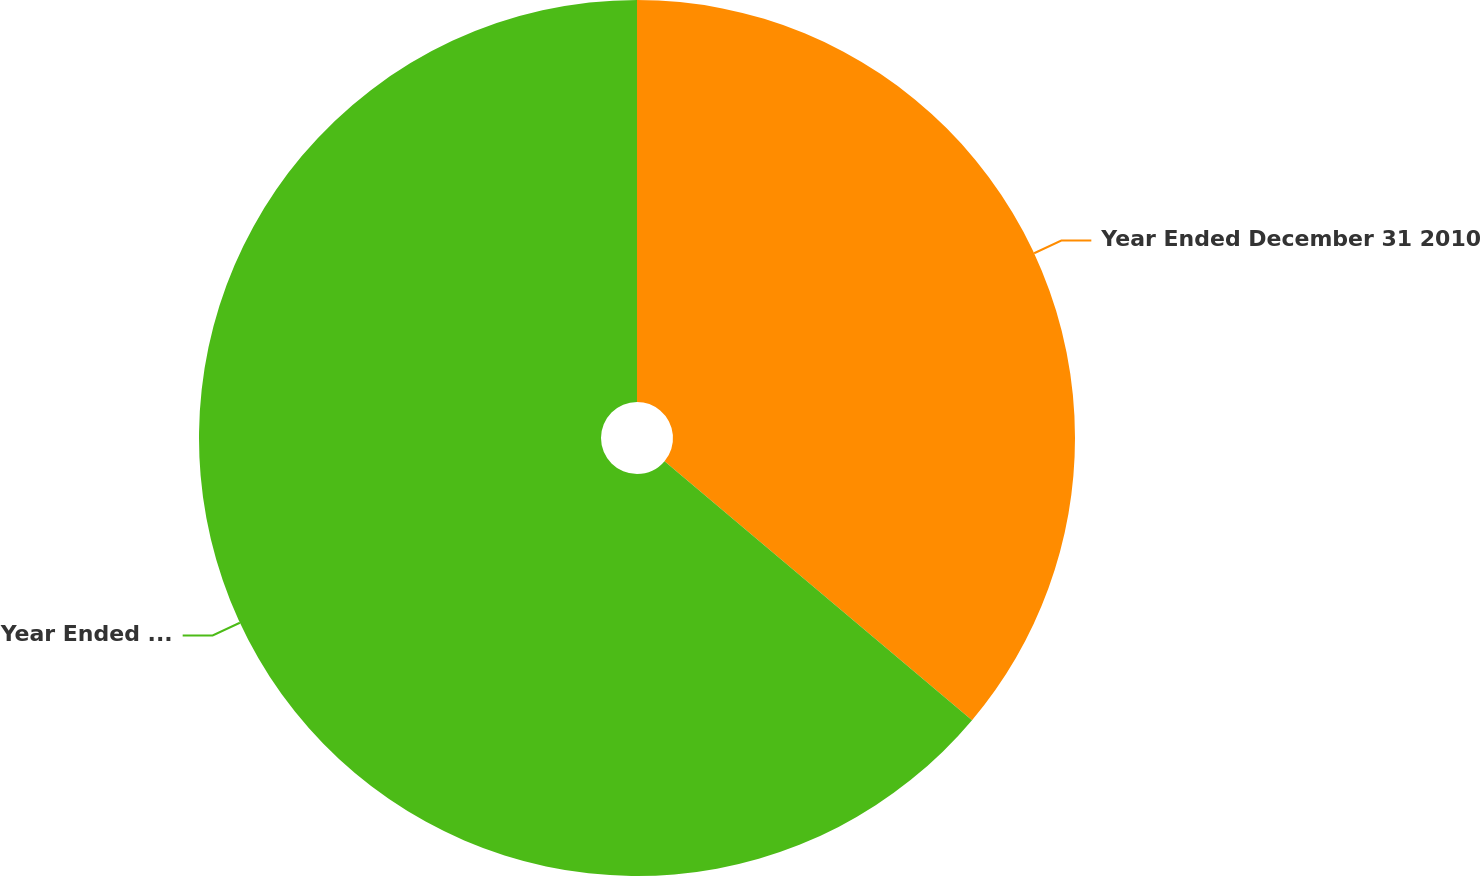Convert chart to OTSL. <chart><loc_0><loc_0><loc_500><loc_500><pie_chart><fcel>Year Ended December 31 2010<fcel>Year Ended December 31 2009<nl><fcel>36.14%<fcel>63.86%<nl></chart> 